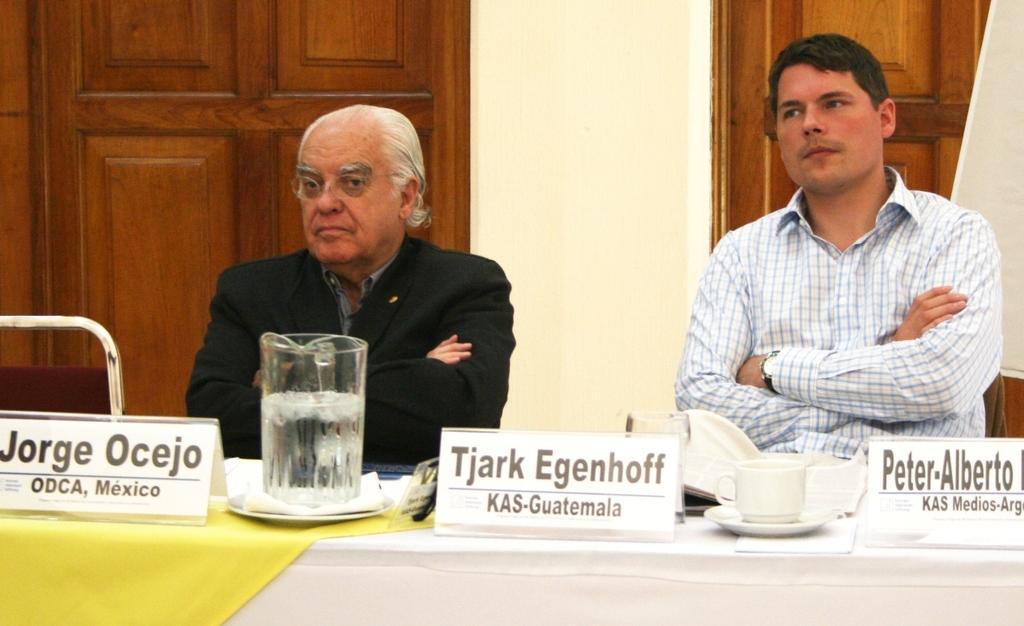Can you describe this image briefly? There are two persons sitting. In front of them there is a table. On the table there is a yellow cloth, there are name plates, cup, saucer, glasses. In the background there is a wall and wooden door. 